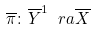<formula> <loc_0><loc_0><loc_500><loc_500>\overline { \pi } \colon \overline { Y } ^ { 1 } \ r a \overline { X }</formula> 